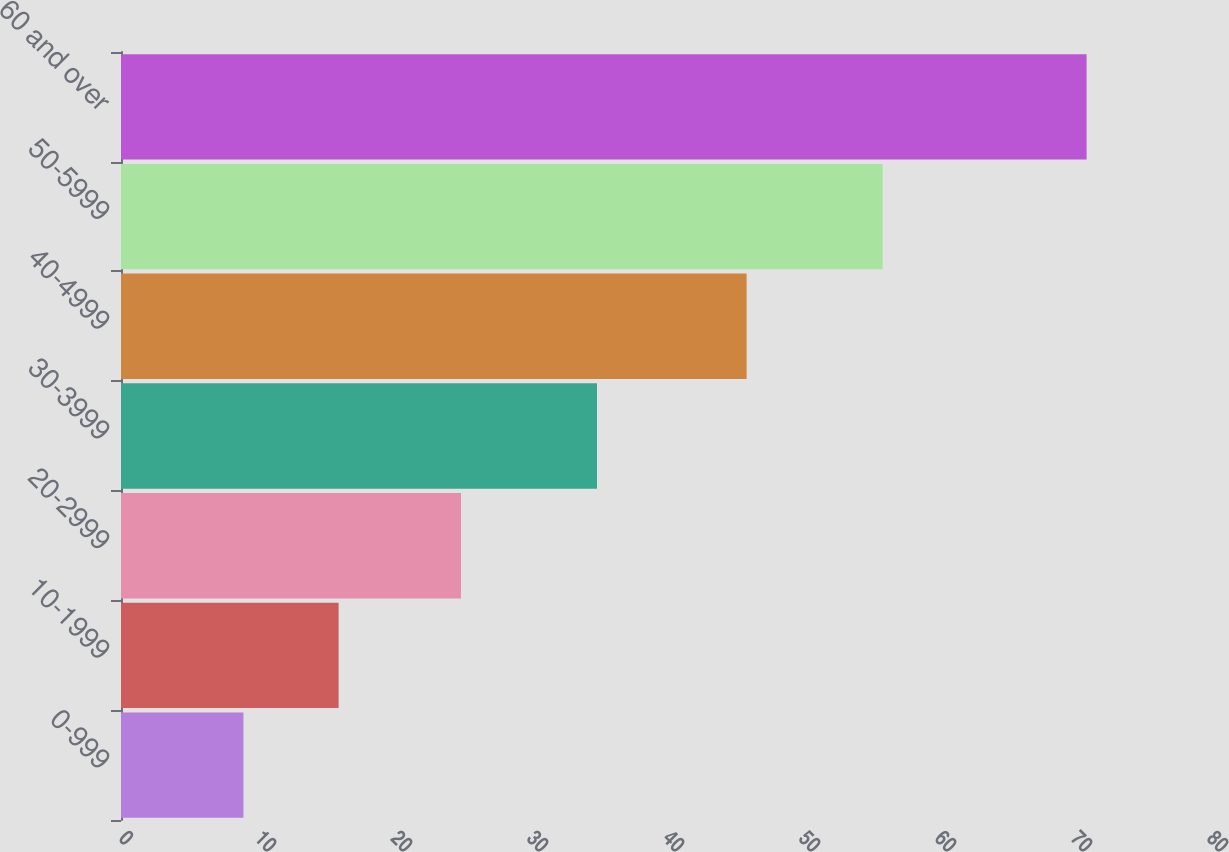<chart> <loc_0><loc_0><loc_500><loc_500><bar_chart><fcel>0-999<fcel>10-1999<fcel>20-2999<fcel>30-3999<fcel>40-4999<fcel>50-5999<fcel>60 and over<nl><fcel>9<fcel>16<fcel>25<fcel>35<fcel>46<fcel>56<fcel>71<nl></chart> 